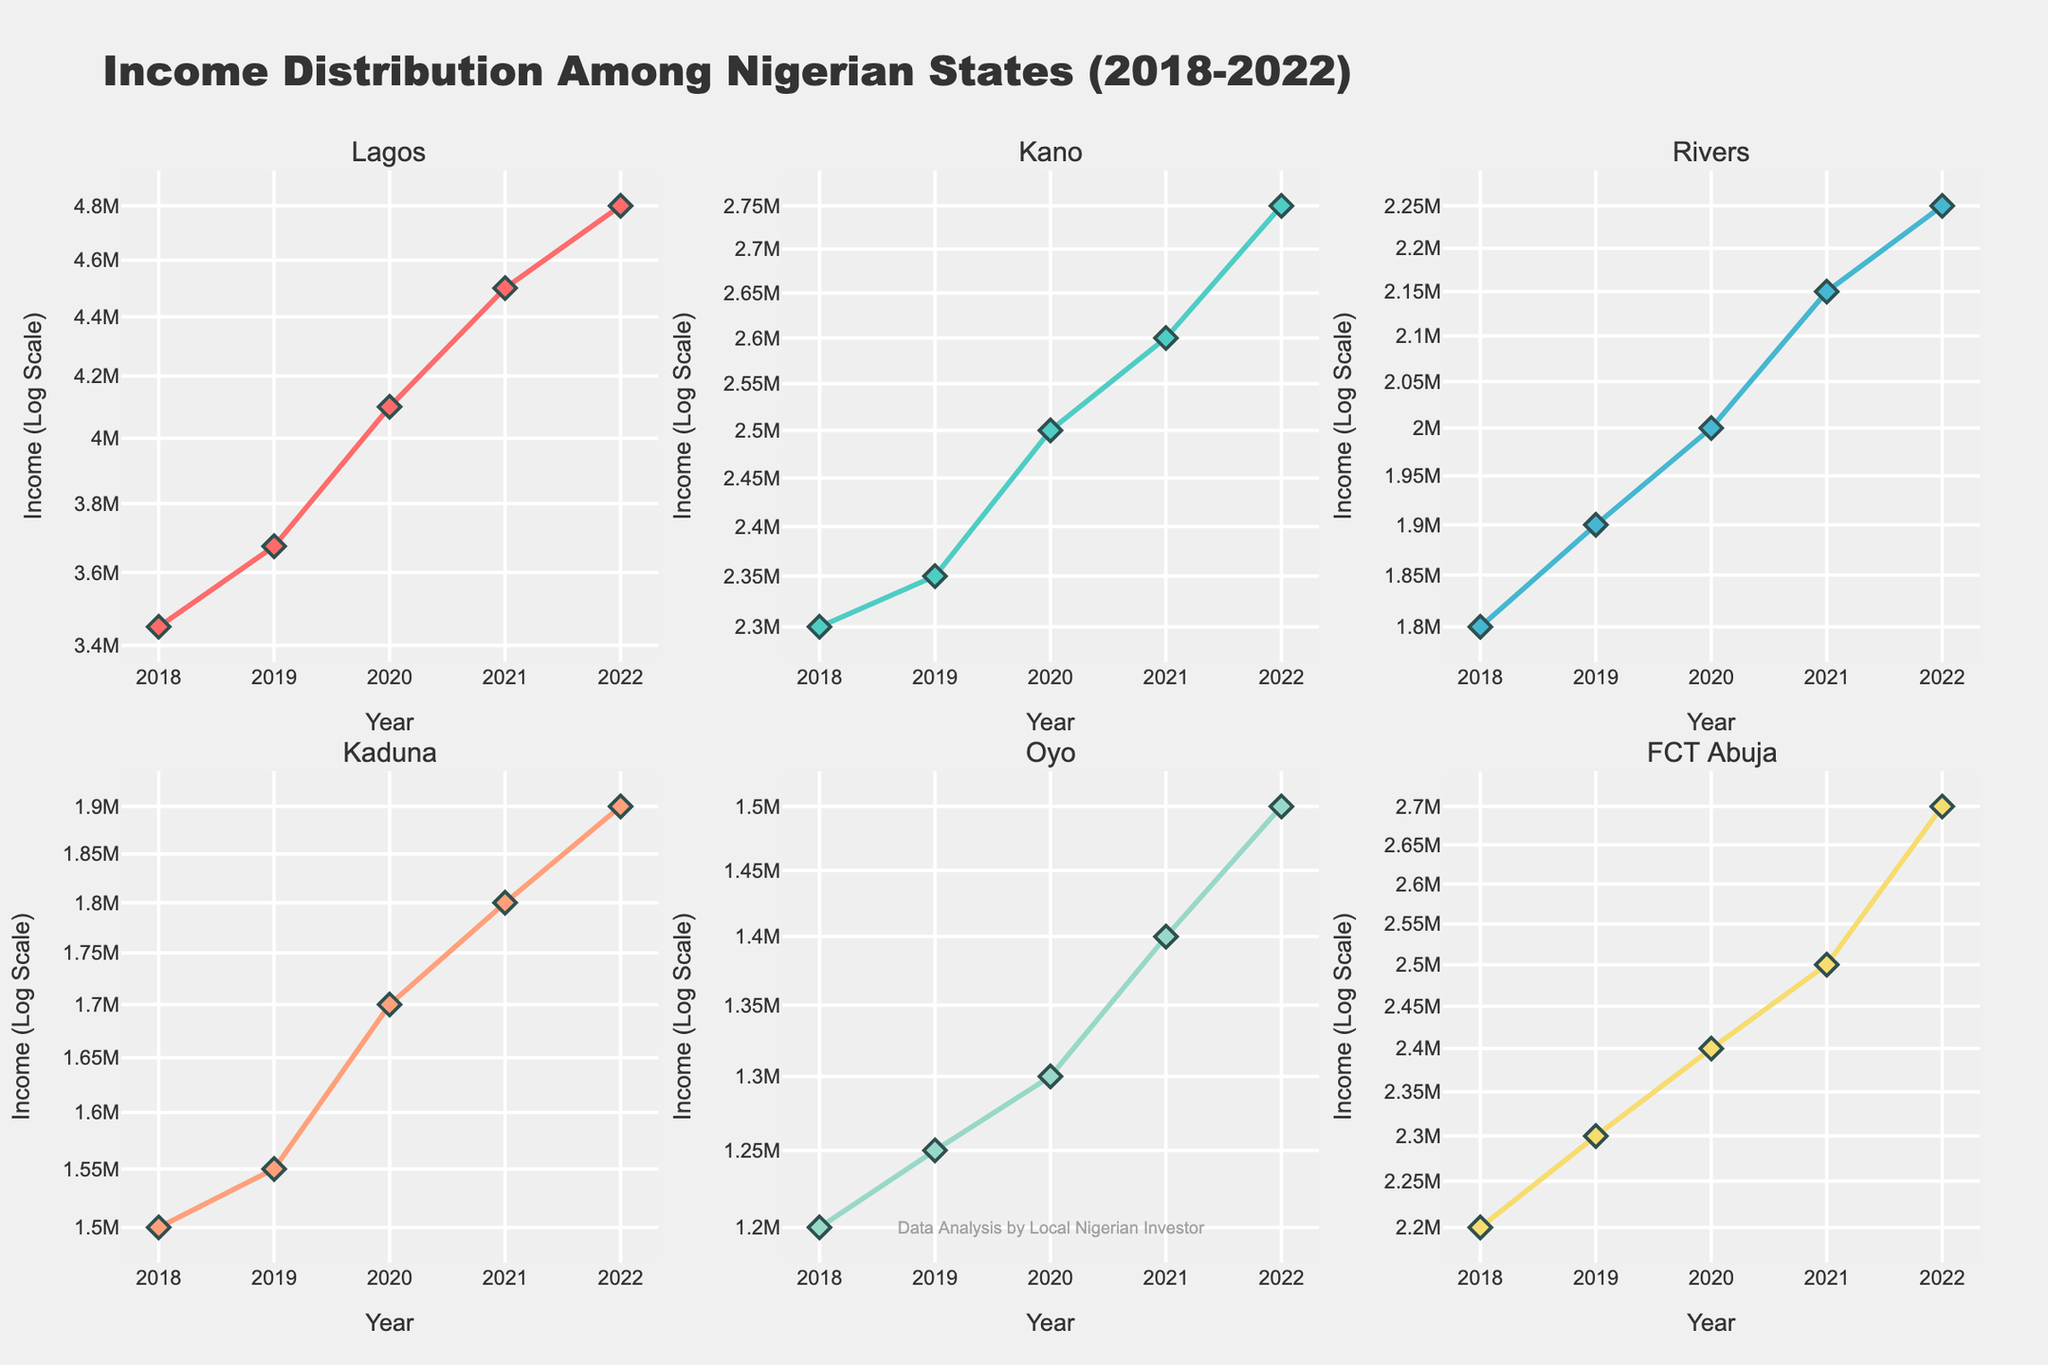What's the title of this figure? The title of the figure is a text element usually located at the top of the plot. By looking at the top of the figure, we can see the full title displayed clearly.
Answer: Income Distribution Among Nigerian States (2018-2022) Which state had the highest income in 2022? We look at the data points for each state in the year 2022 and compare them. Lagos has the highest income at ₦4,800,000.
Answer: Lagos What's the trend of income for Lagos from 2018 to 2022? By observing the plot specific to Lagos, we notice that the line representing Lagos's income rises consistently each year from 2018 to 2022, indicating a steady upward trend.
Answer: Steady increase How does the income of Rivers in 2018 compare to that in 2020? We find the income values for Rivers in 2018 and 2020 from the subplot and then compare them. Rivers' income increased from ₦1,800,000 in 2018 to ₦2,000,000 in 2020.
Answer: Increased Which state's income showed the least variation from 2018 to 2022? We need to identify the state with the least fluctuation in income by looking at the height of the line segments in each subplot. Kano's income exhibits the least variation given its smaller range of values.
Answer: Kano What is the average income of Kaduna over the five years? We sum the income values for Kaduna from 2018 to 2022 and divide by 5: (₦1,500,000 + ₦1,550,000 + ₦1,700,000 + ₦1,800,000 + ₦1,900,000) / 5, which would be calculated as follows: (7500000/5).
Answer: ₦1,650,000 Compare the growth rate of income of Lagos and Oyo between 2019 and 2020. Which state had a higher growth rate? We calculate the percentage growth for both states between 2019 and 2020. For Lagos: ((₦4,100,000 - ₦3,675,000) / ₦3,675,000) * 100 ≈ 11.6%. For Oyo: ((₦1,300,000 - ₦1,250,000) / ₦1,250,000) * 100 = 4%. Lagos had a higher growth rate.
Answer: Lagos What is the log base used in the y-axis of the figure? By referring to the y-axis label, we can determine that the axis is on a logarithmic scale and commonly uses base 10.
Answer: Base 10 Which state had the second-highest income in 2022? By observing the y-axis values for the year 2022 across all subplots, we see that Kano follows Lagos with the second-highest income of ₦2,750,000.
Answer: Kano 